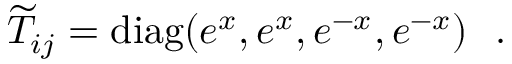<formula> <loc_0><loc_0><loc_500><loc_500>{ \widetilde { T } } _ { i j } = d i a g ( e ^ { x } , e ^ { x } , e ^ { - x } , e ^ { - x } ) .</formula> 